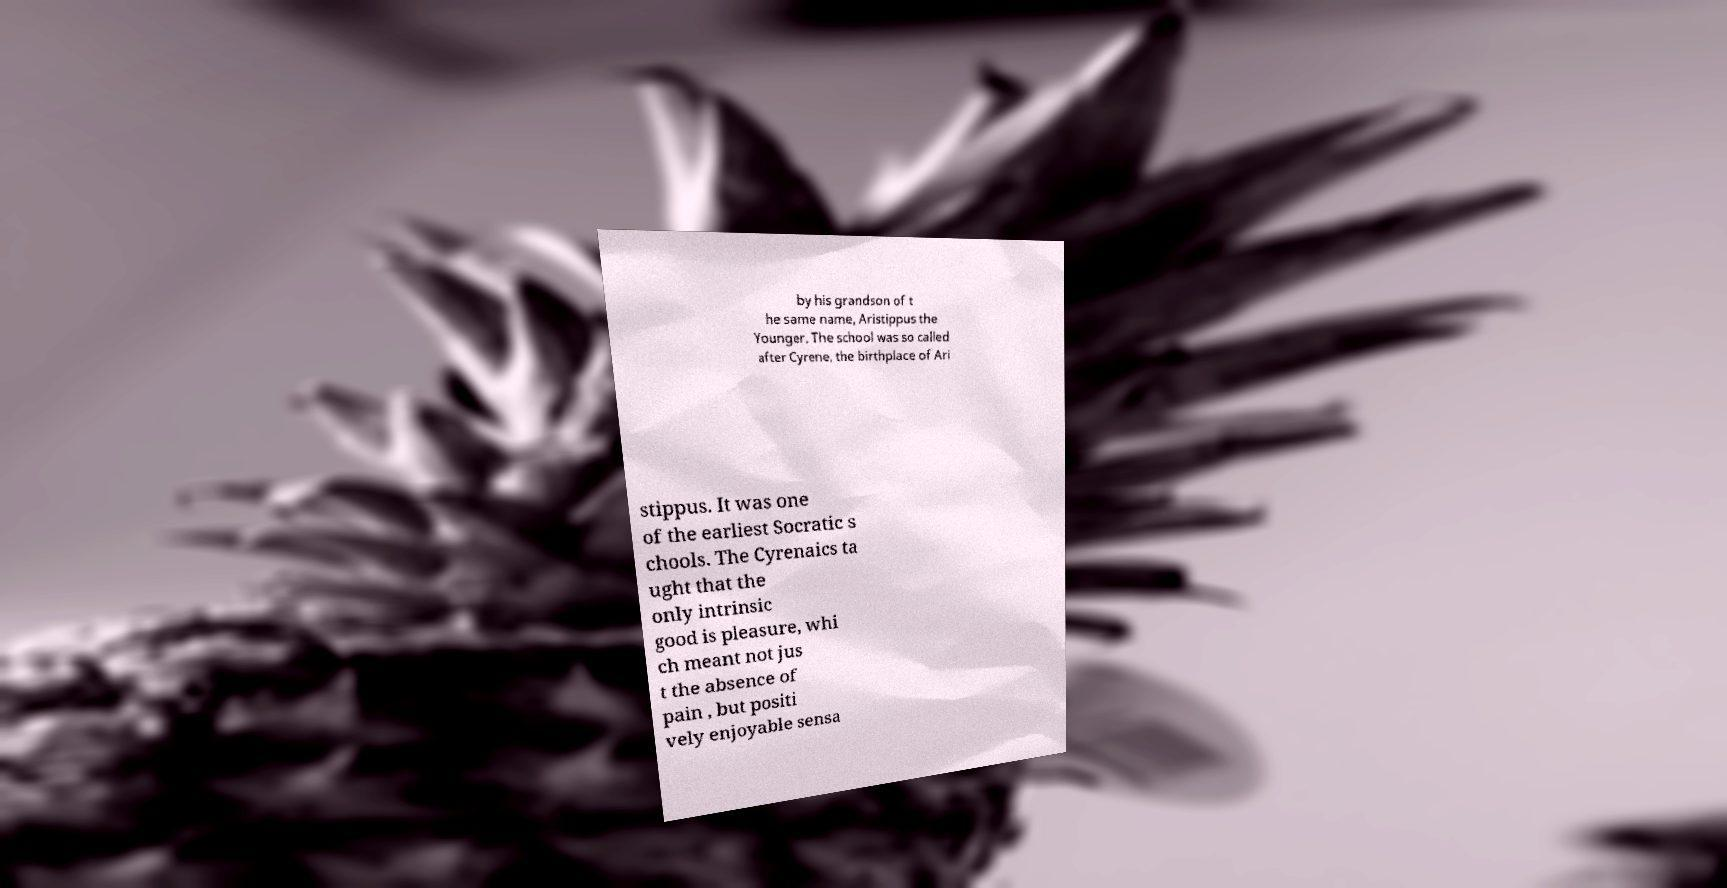What messages or text are displayed in this image? I need them in a readable, typed format. by his grandson of t he same name, Aristippus the Younger. The school was so called after Cyrene, the birthplace of Ari stippus. It was one of the earliest Socratic s chools. The Cyrenaics ta ught that the only intrinsic good is pleasure, whi ch meant not jus t the absence of pain , but positi vely enjoyable sensa 